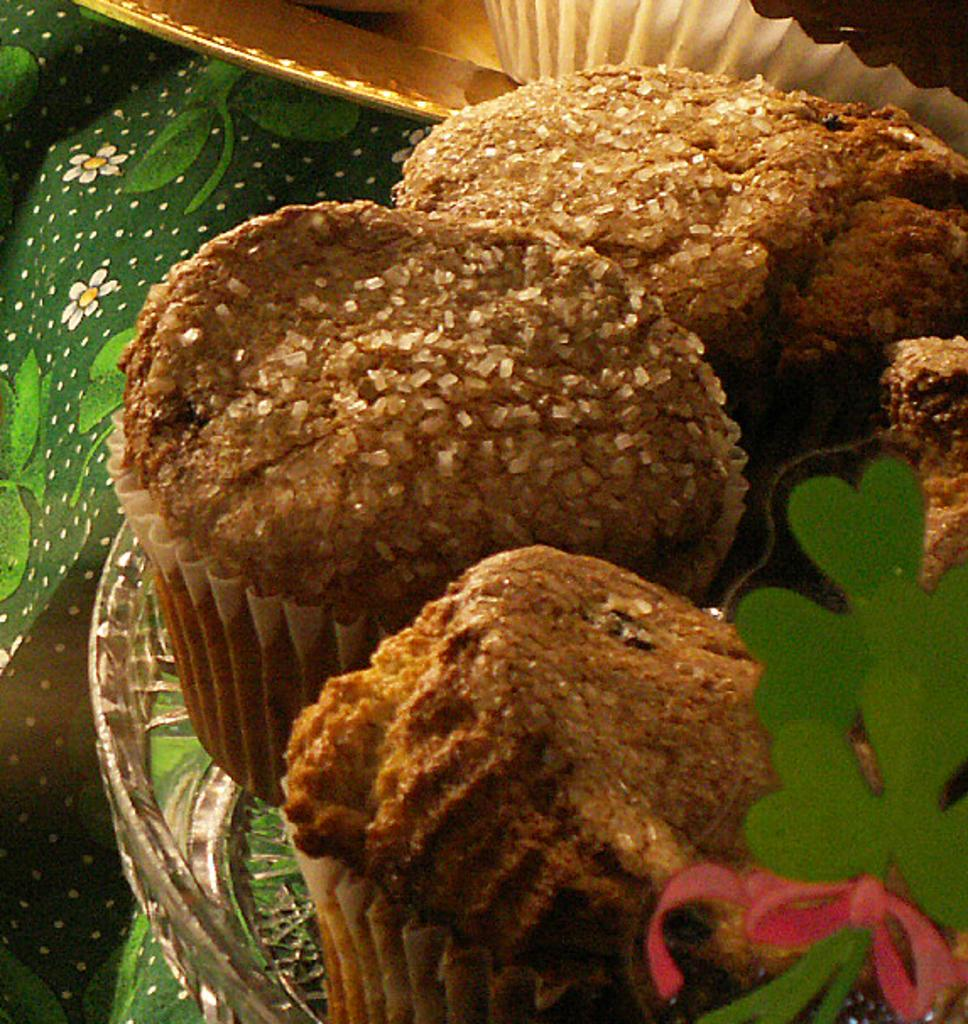What type of dessert can be seen in the image? There are cupcakes in the image. What is the cupcakes resting on? The cupcakes are on a glass plate. How are the cupcakes arranged on the plate? The cupcakes are arranged one beside the other. What type of bird can be seen flying over the cupcakes in the image? There is no bird present in the image; it only features cupcakes on a glass plate. 